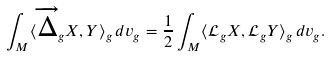Convert formula to latex. <formula><loc_0><loc_0><loc_500><loc_500>\int _ { M } \langle \overrightarrow { \Delta } _ { g } X , Y \rangle _ { g } \, d v _ { g } = \frac { 1 } { 2 } \int _ { M } \langle \mathcal { L } _ { g } X , \mathcal { L } _ { g } Y \rangle _ { g } \, d v _ { g } .</formula> 